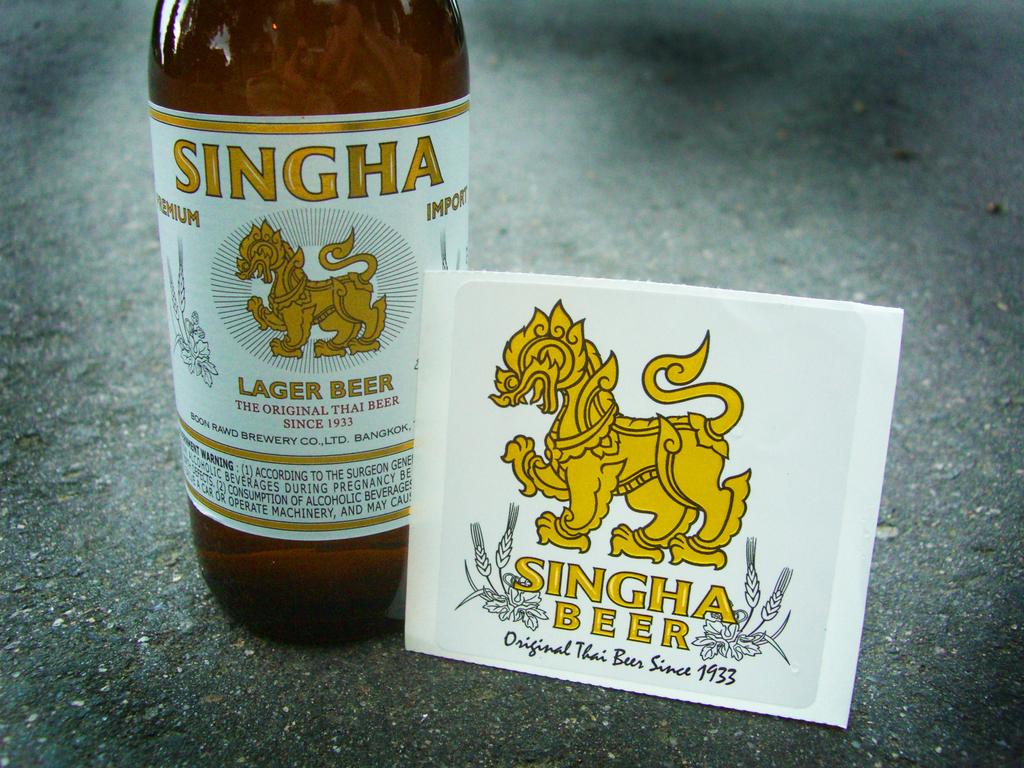What kind of beer is it?
Make the answer very short. Singha beer. 